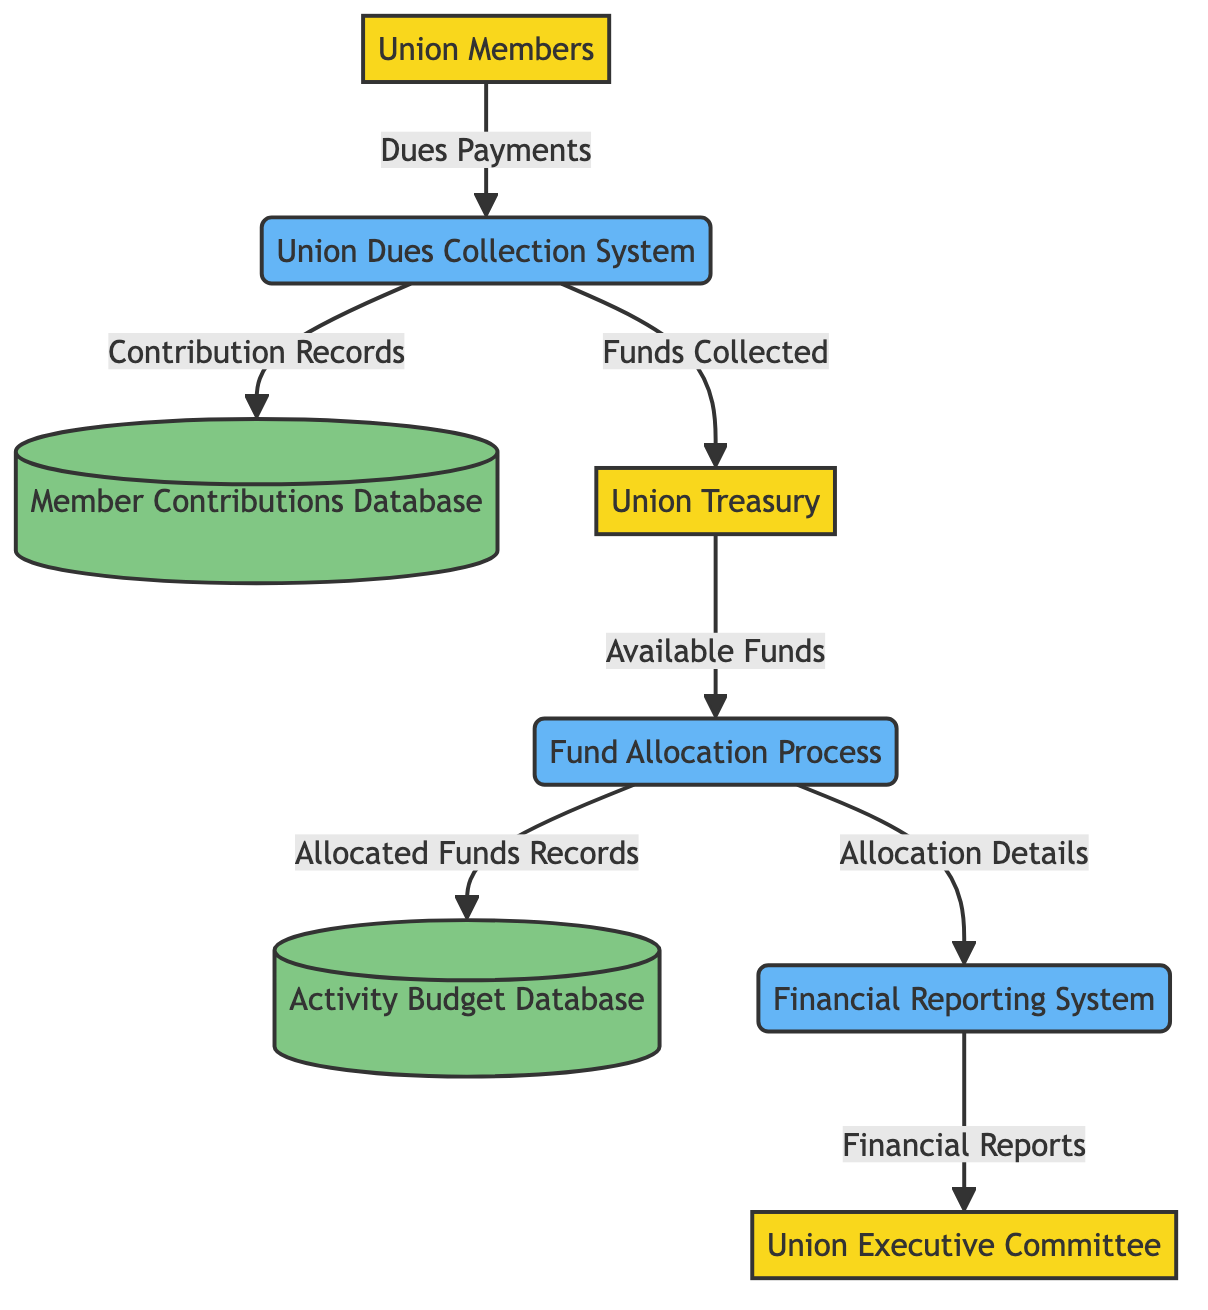What are Union Members contributing? The Union Members are contributing "Dues Payments" to the Union Dues Collection System, which is the first data flow in the diagram.
Answer: Dues Payments How many processes are in the diagram? The diagram features four processes: Union Dues Collection System, Fund Allocation Process, and Financial Reporting System. Therefore, the count is three.
Answer: Three What does the Union Dues Collection System output to the Member Contributions Database? The Union Dues Collection System outputs "Contribution Records" to the Member Contributions Database, as indicated by the arrow connecting these two nodes.
Answer: Contribution Records Which external entity receives the Financial Reports? The Financial Reporting System sends the "Financial Reports" to the Union Executive Committee, which is the external entity receiving this information.
Answer: Union Executive Committee What data flows from the Union Treasury? The Union Treasury provides "Available Funds" to the Fund Allocation Process, which is a key flow in managing fund allocations from the collected dues.
Answer: Available Funds What is stored in the Activity Budget Database? The Activity Budget Database maintains "Allocated Funds Records," which detail how the collected funds have been distributed for various union activities.
Answer: Allocated Funds Records What role does the Fund Allocation Process serve after receiving funds from the Union Treasury? The Fund Allocation Process oversees the distribution of "Allocated Funds Records" to the Activity Budget Database and details for the Financial Reporting System, enabling accountability and planning for union activities.
Answer: Fund Distribution Which system is responsible for collecting dues from members? The system responsible for collecting dues from members is the Union Dues Collection System, as shown in the diagram.
Answer: Union Dues Collection System What kind of data does the Financial Reporting System generate? The Financial Reporting System generates "Financial Reports," providing a crucial overview of the financial activities related to dues and funds, showcasing the collected amounts and allocations.
Answer: Financial Reports 